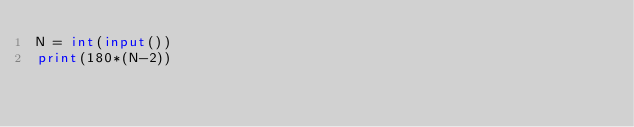Convert code to text. <code><loc_0><loc_0><loc_500><loc_500><_Python_>N = int(input())
print(180*(N-2))
</code> 